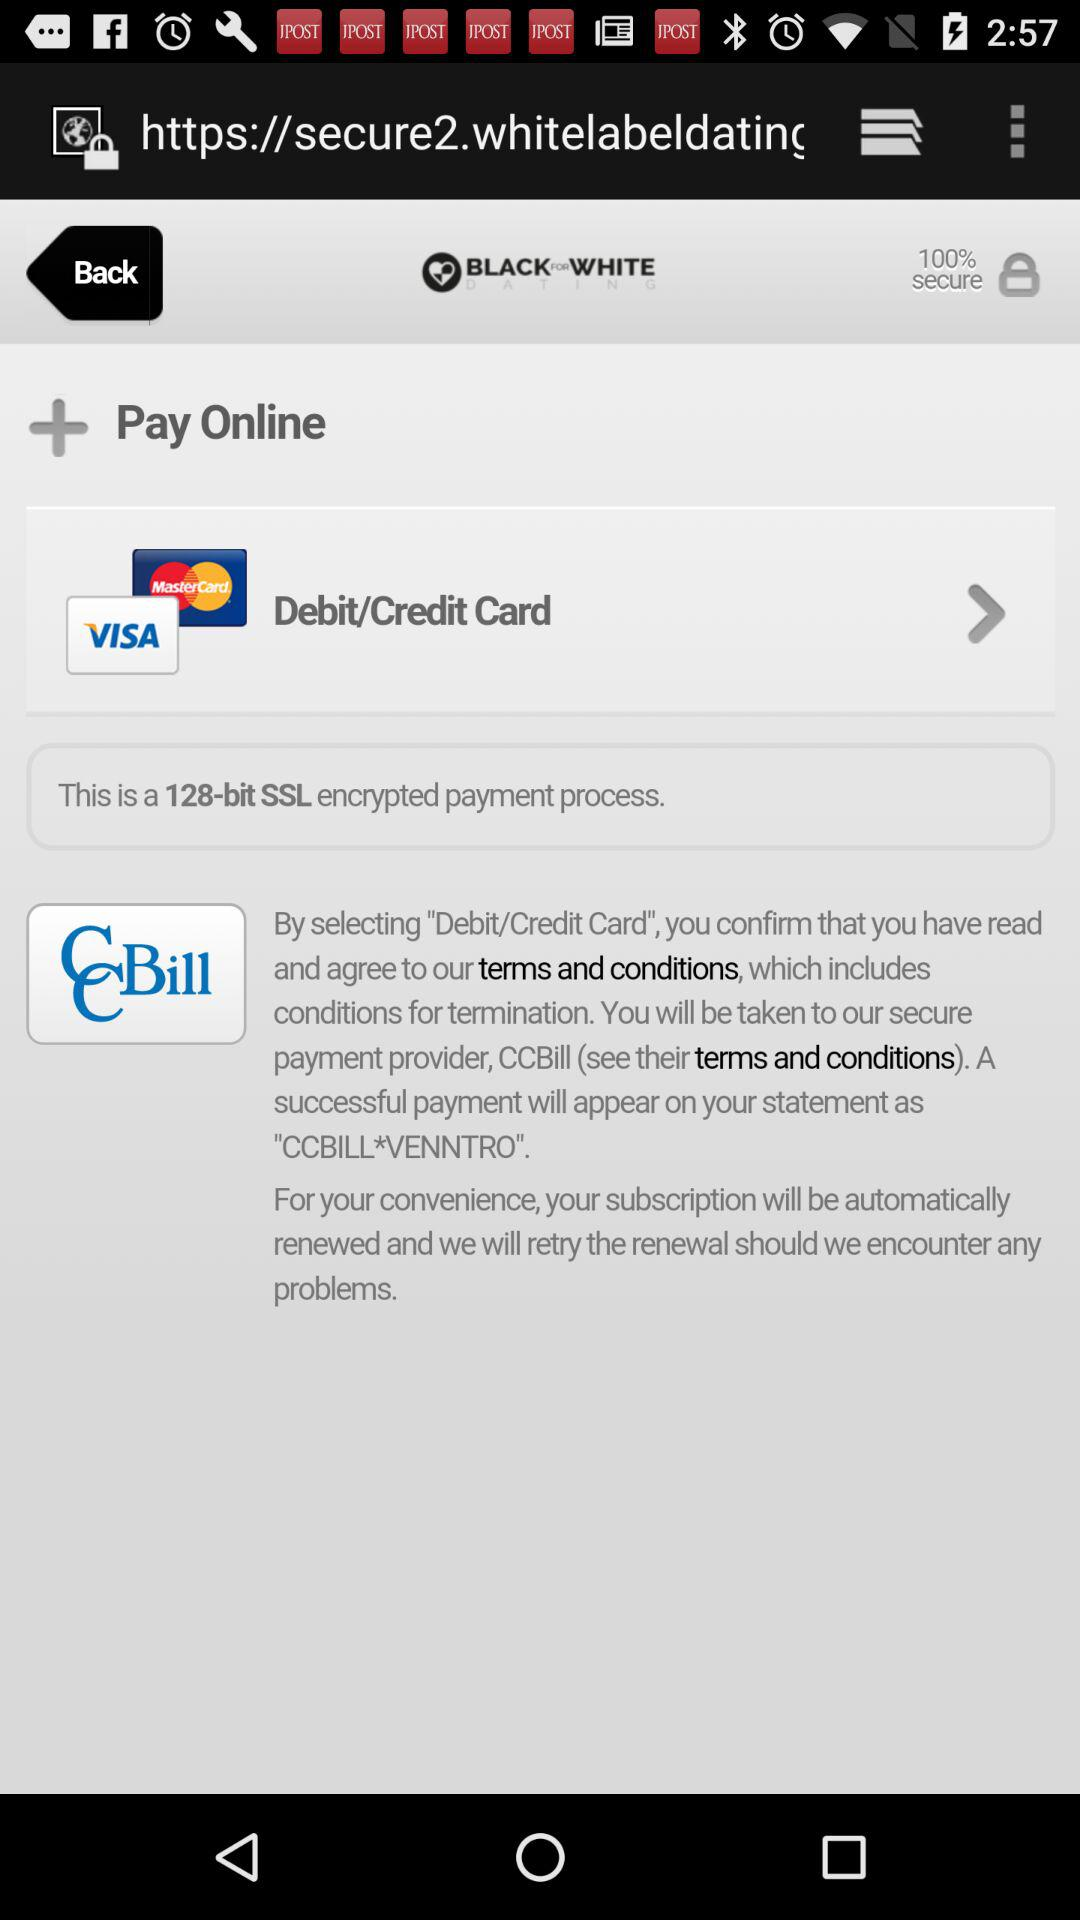What is the email address? The email address is appcrawler5@gmail.com. 